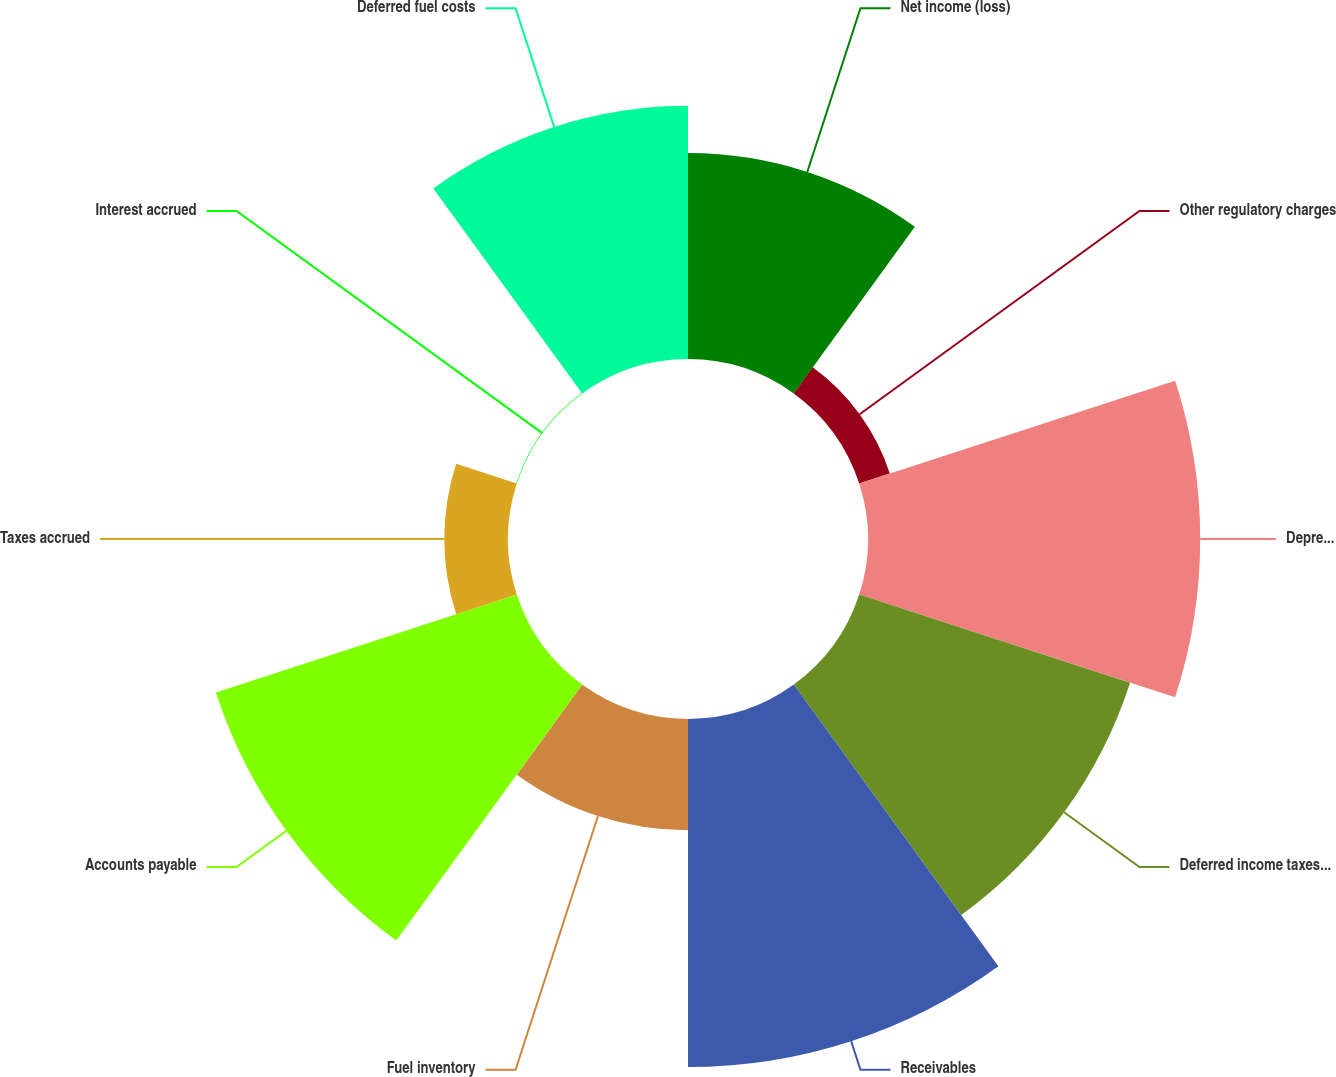Convert chart to OTSL. <chart><loc_0><loc_0><loc_500><loc_500><pie_chart><fcel>Net income (loss)<fcel>Other regulatory charges<fcel>Depreciation and amortization<fcel>Deferred income taxes and<fcel>Receivables<fcel>Fuel inventory<fcel>Accounts payable<fcel>Taxes accrued<fcel>Interest accrued<fcel>Deferred fuel costs<nl><fcel>10.57%<fcel>1.65%<fcel>17.05%<fcel>14.62%<fcel>17.86%<fcel>5.71%<fcel>16.24%<fcel>3.27%<fcel>0.03%<fcel>13.0%<nl></chart> 